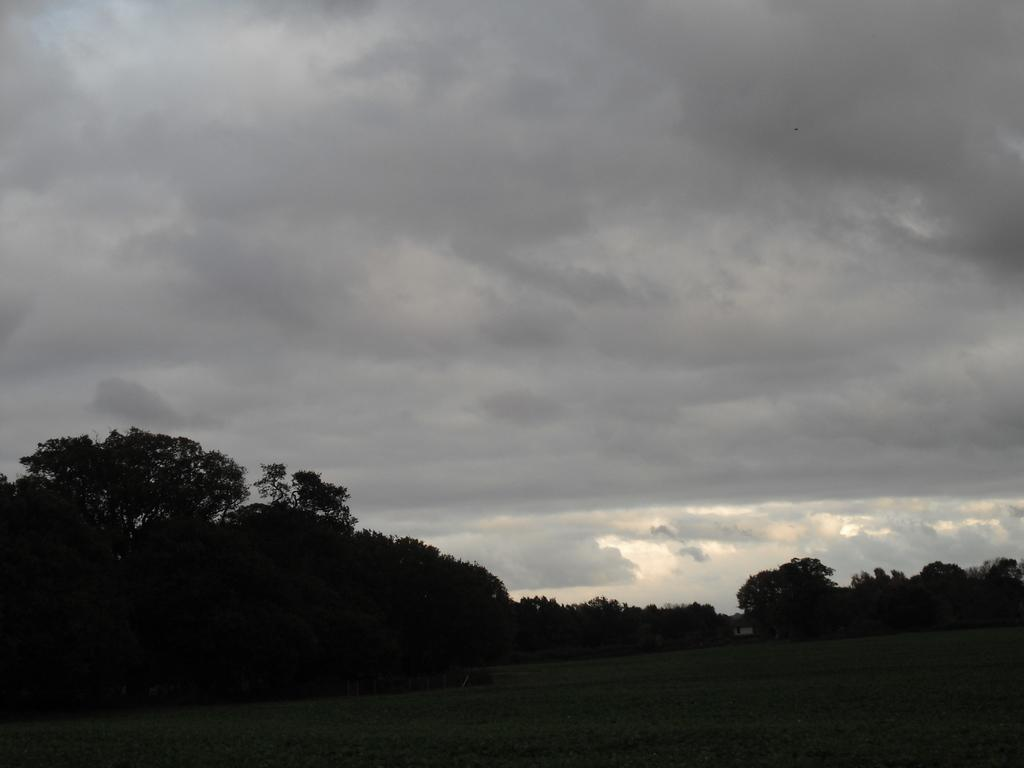What can be seen at the base of the image? The ground is visible in the image. What type of vegetation is present in the image? There are many trees in the image. What is visible in the background of the image? The clouds and the sky are visible in the background of the image. Is there a bear covered in hot lava in the image? No, there is no bear or hot lava present in the image. 